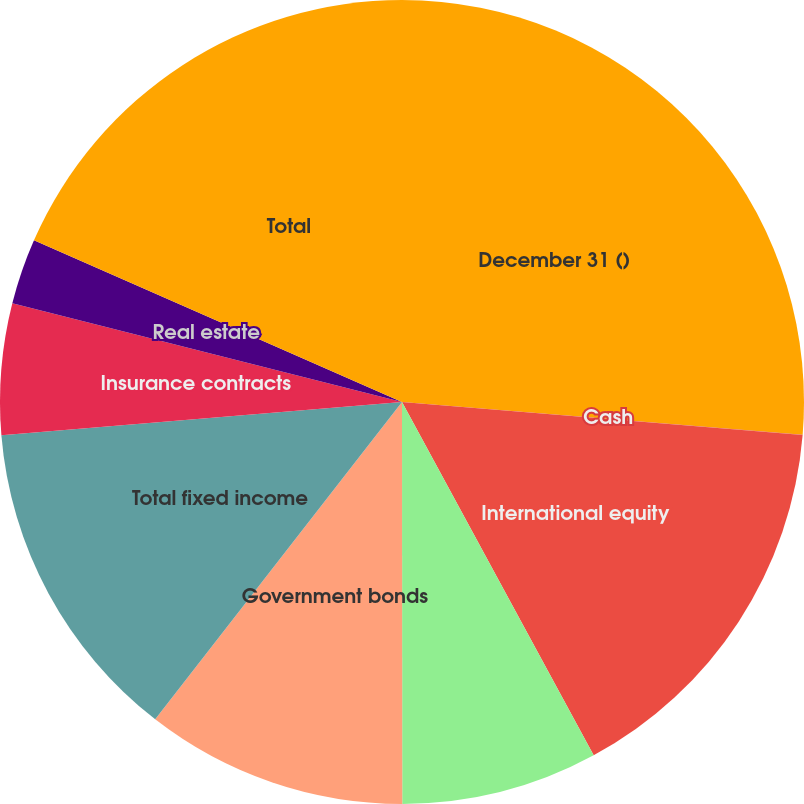Convert chart. <chart><loc_0><loc_0><loc_500><loc_500><pie_chart><fcel>December 31 ()<fcel>Cash<fcel>International equity<fcel>Corporate bonds<fcel>Government bonds<fcel>Total fixed income<fcel>Insurance contracts<fcel>Real estate<fcel>Total<nl><fcel>26.3%<fcel>0.01%<fcel>15.78%<fcel>7.9%<fcel>10.53%<fcel>13.16%<fcel>5.27%<fcel>2.64%<fcel>18.41%<nl></chart> 